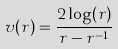Convert formula to latex. <formula><loc_0><loc_0><loc_500><loc_500>v ( r ) = \frac { 2 \log ( r ) } { r - r ^ { - 1 } }</formula> 